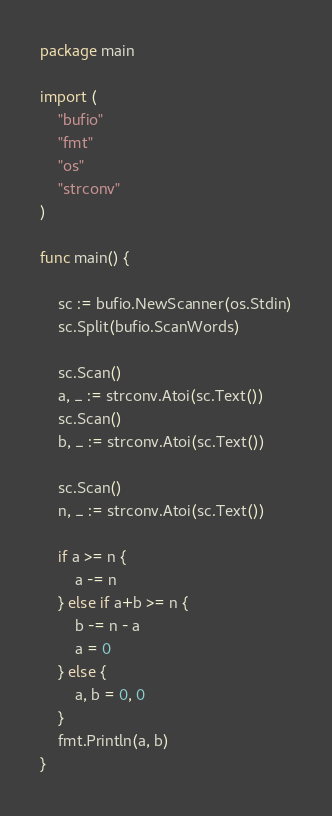Convert code to text. <code><loc_0><loc_0><loc_500><loc_500><_Go_>package main

import (
	"bufio"
	"fmt"
	"os"
	"strconv"
)

func main() {

	sc := bufio.NewScanner(os.Stdin)
	sc.Split(bufio.ScanWords)

	sc.Scan()
	a, _ := strconv.Atoi(sc.Text())
	sc.Scan()
	b, _ := strconv.Atoi(sc.Text())

	sc.Scan()
	n, _ := strconv.Atoi(sc.Text())

	if a >= n {
		a -= n
	} else if a+b >= n {
		b -= n - a
		a = 0
	} else {
		a, b = 0, 0
	}
	fmt.Println(a, b)
}
</code> 